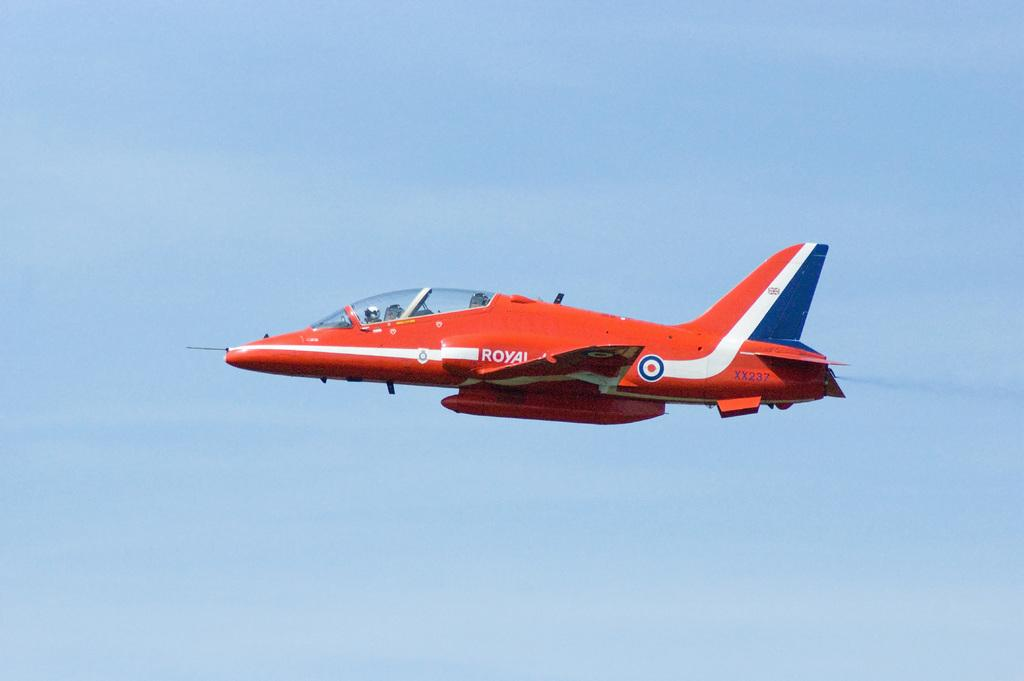What is the main subject of the picture? The main subject of the picture is an airplane. What is the color of the airplane? The airplane is red in color. What is the airplane doing in the image? The airplane is flying in the sky. What can be seen in the background of the image? The sky is visible in the background of the image. What is the color of the sky in the image? The sky is blue in color. What type of beef can be seen being prepared in the image? There is no beef present in the image; it features an airplane flying in the sky. What is the cause of the loss experienced by the airplane in the image? There is no loss experienced by the airplane in the image; it is simply flying in the sky. 